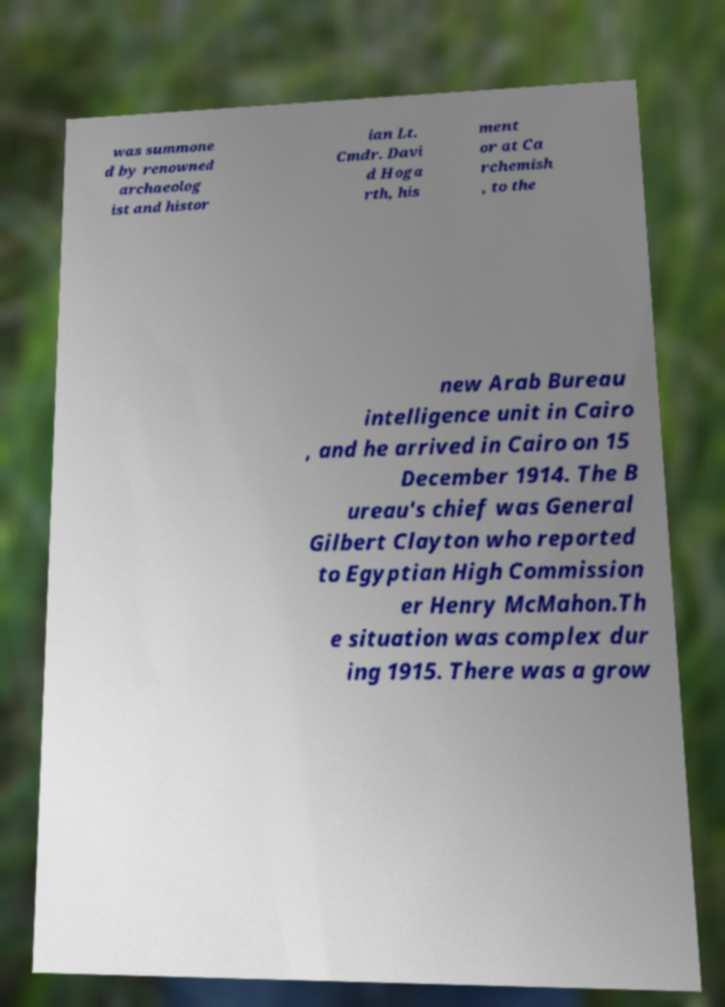Can you accurately transcribe the text from the provided image for me? was summone d by renowned archaeolog ist and histor ian Lt. Cmdr. Davi d Hoga rth, his ment or at Ca rchemish , to the new Arab Bureau intelligence unit in Cairo , and he arrived in Cairo on 15 December 1914. The B ureau's chief was General Gilbert Clayton who reported to Egyptian High Commission er Henry McMahon.Th e situation was complex dur ing 1915. There was a grow 